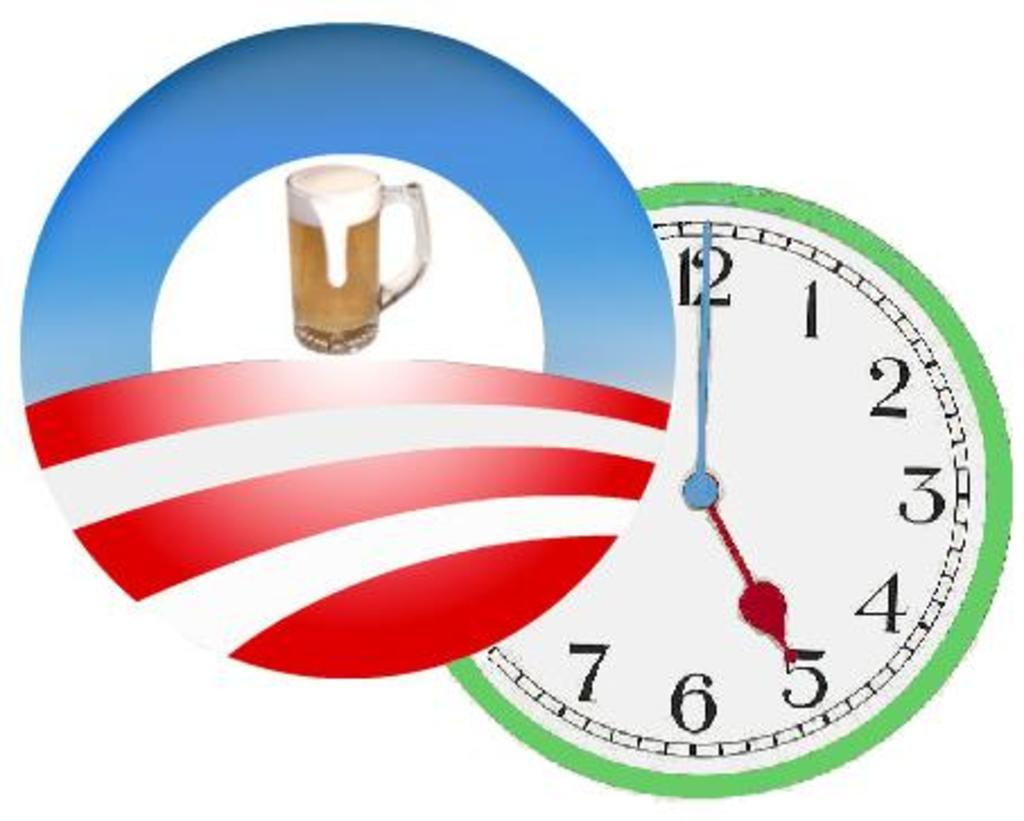<image>
Provide a brief description of the given image. the numbers 1 to 12 that are on a clock 